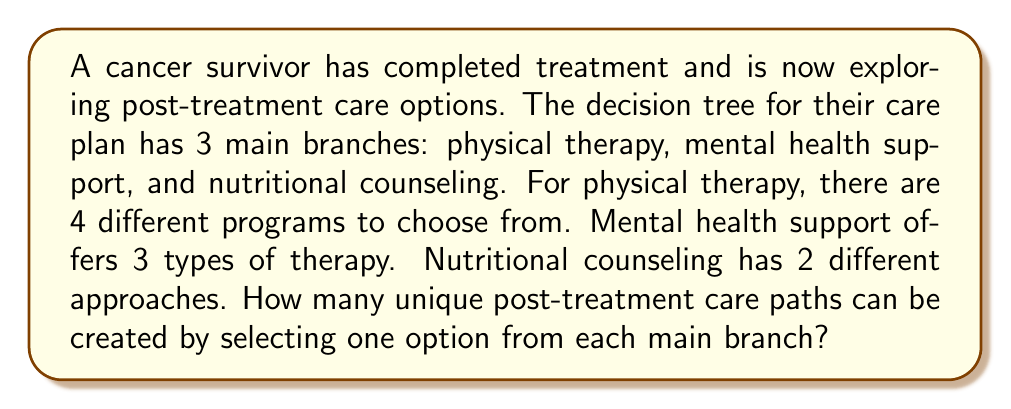Provide a solution to this math problem. To solve this problem, we'll use the multiplication principle of counting. This principle states that if we have a sequence of independent choices, the total number of possible outcomes is the product of the number of options for each choice.

Let's break it down step-by-step:

1. Physical therapy options: 4 choices
2. Mental health support options: 3 choices
3. Nutritional counseling options: 2 choices

For each main branch, the survivor must choose exactly one option. The choices in each branch are independent of the others.

Therefore, the total number of unique paths is:

$$ \text{Total paths} = 4 \times 3 \times 2 $$

Calculating this:

$$ \text{Total paths} = 24 $$

This means there are 24 different ways to create a post-treatment care plan by selecting one option from each of the three main branches.
Answer: 24 